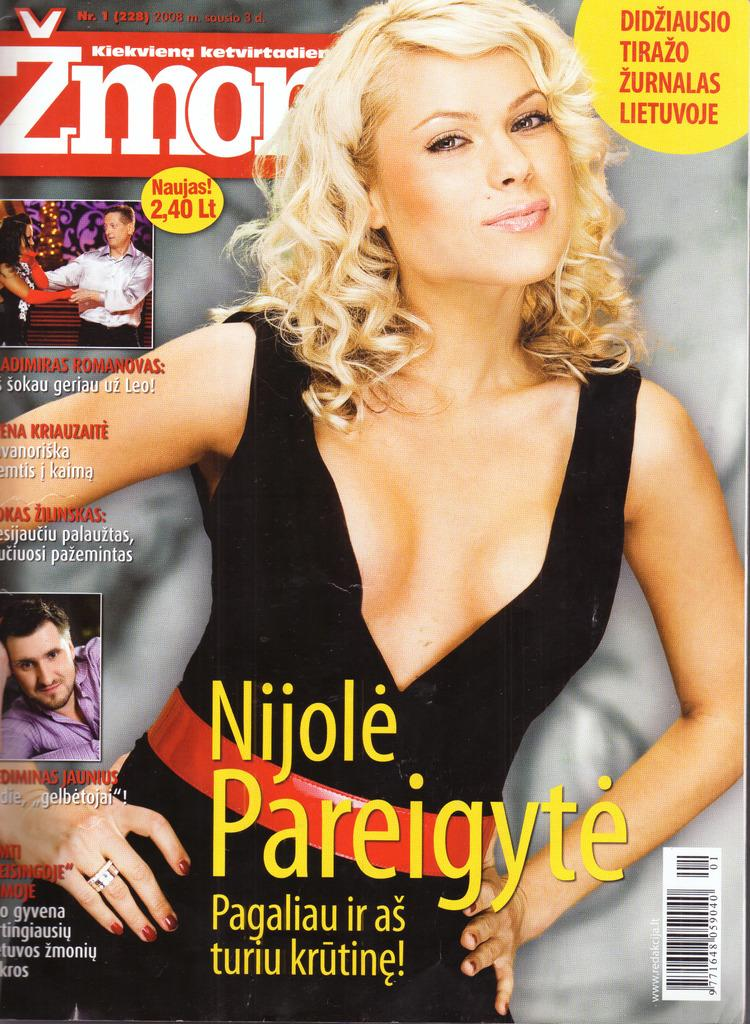What type of image is depicted in the given facts? The image appears to be a poster. Who or what is the main subject of the poster? There is a woman in the middle of the poster. What else can be found on the poster besides the woman? There is text at the bottom of the poster and men on the left side of the poster. Is there a bathtub visible in the poster? No, there is no bathtub present in the poster. Can you see a basketball being played in the poster? No, there is no basketball or any indication of a game being played in the poster. 